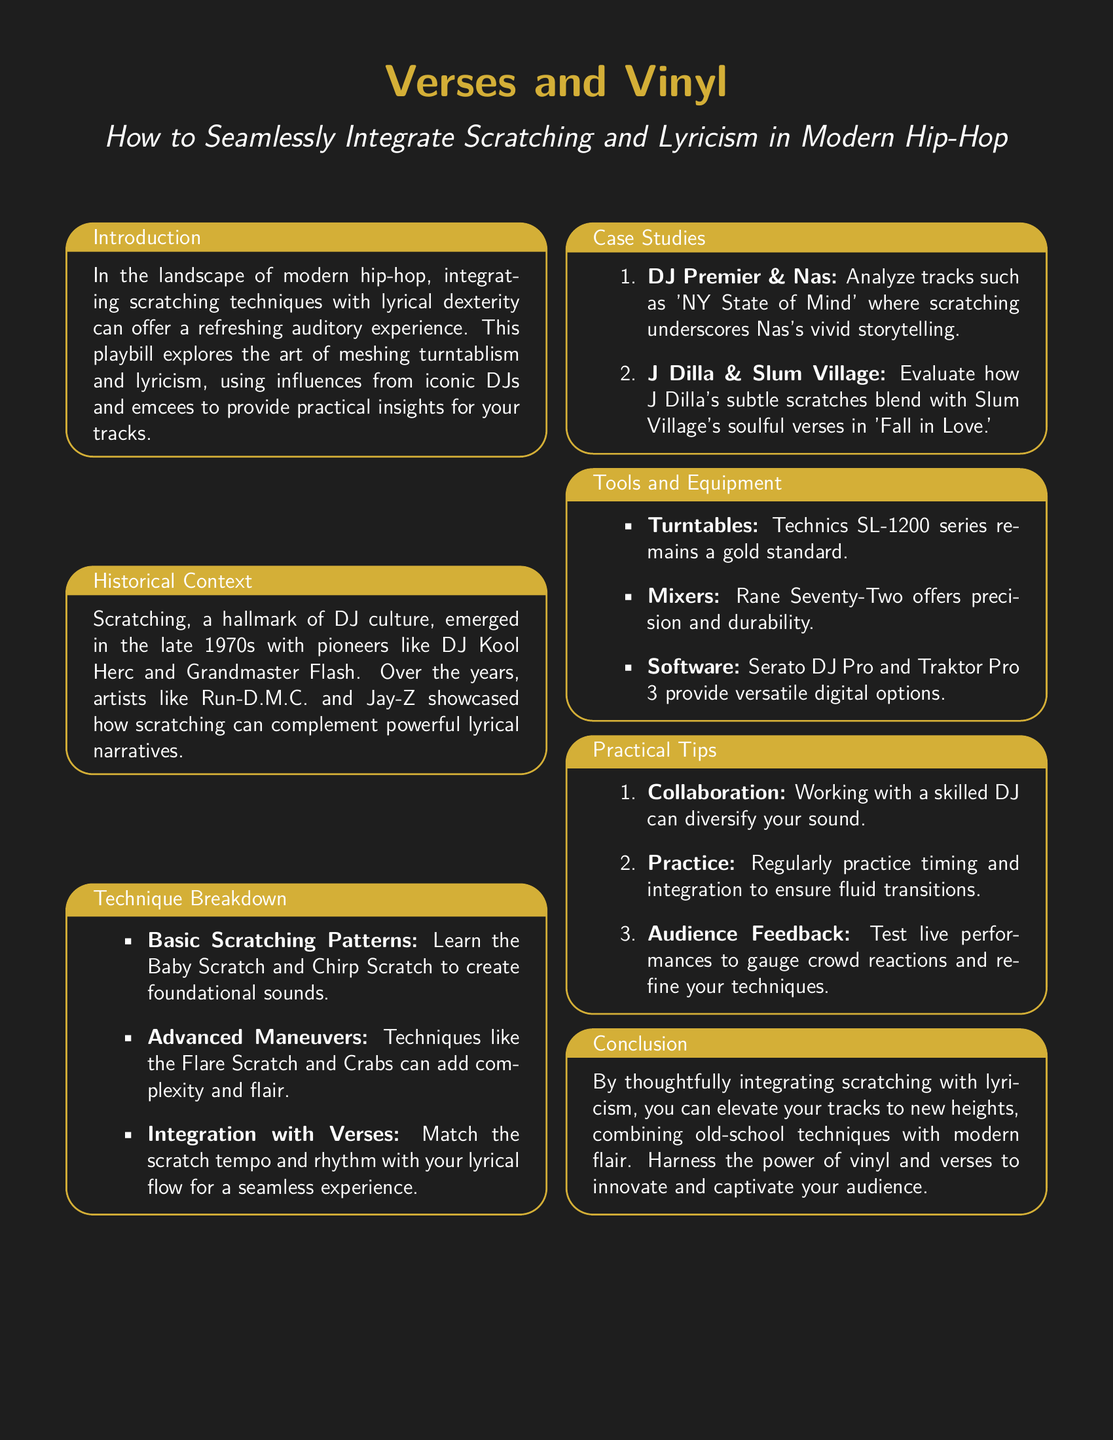What are the two main elements explored in the playbill? The playbill focuses on the integration of scratching and lyricism within modern hip-hop.
Answer: Scratching and lyricism Who were the first pioneers of scratching mentioned? The document specifies DJ Kool Herc and Grandmaster Flash as the early pioneers of scratching.
Answer: DJ Kool Herc and Grandmaster Flash What is one basic scratching pattern introduced? The playbill mentions the Baby Scratch as a fundamental scratching technique to learn.
Answer: Baby Scratch What tracks are analyzed in the case studies? The document analyzes 'NY State of Mind' by DJ Premier and Nas, and 'Fall in Love' by J Dilla and Slum Village.
Answer: NY State of Mind and Fall in Love Which turntables are considered the gold standard? The Technics SL-1200 series is highlighted as the gold standard for turntables.
Answer: Technics SL-1200 series What is emphasized as an important aspect for collaborating with DJs? The playbill emphasizes that working with a skilled DJ can diversify your sound.
Answer: Skilled DJ What type of software options are mentioned for digital scratching? Serato DJ Pro and Traktor Pro 3 are noted as versatile software options for digital scratching.
Answer: Serato DJ Pro and Traktor Pro 3 What does the conclusion suggest about integrating scratching with lyricism? It suggests that thoughtful integration can elevate tracks and combine old-school techniques with modern flair.
Answer: Elevate tracks What does the section on technique breakdown focus on? This section discusses basic and advanced scratching techniques alongside their integration with verses.
Answer: Basic and advanced scratching techniques 